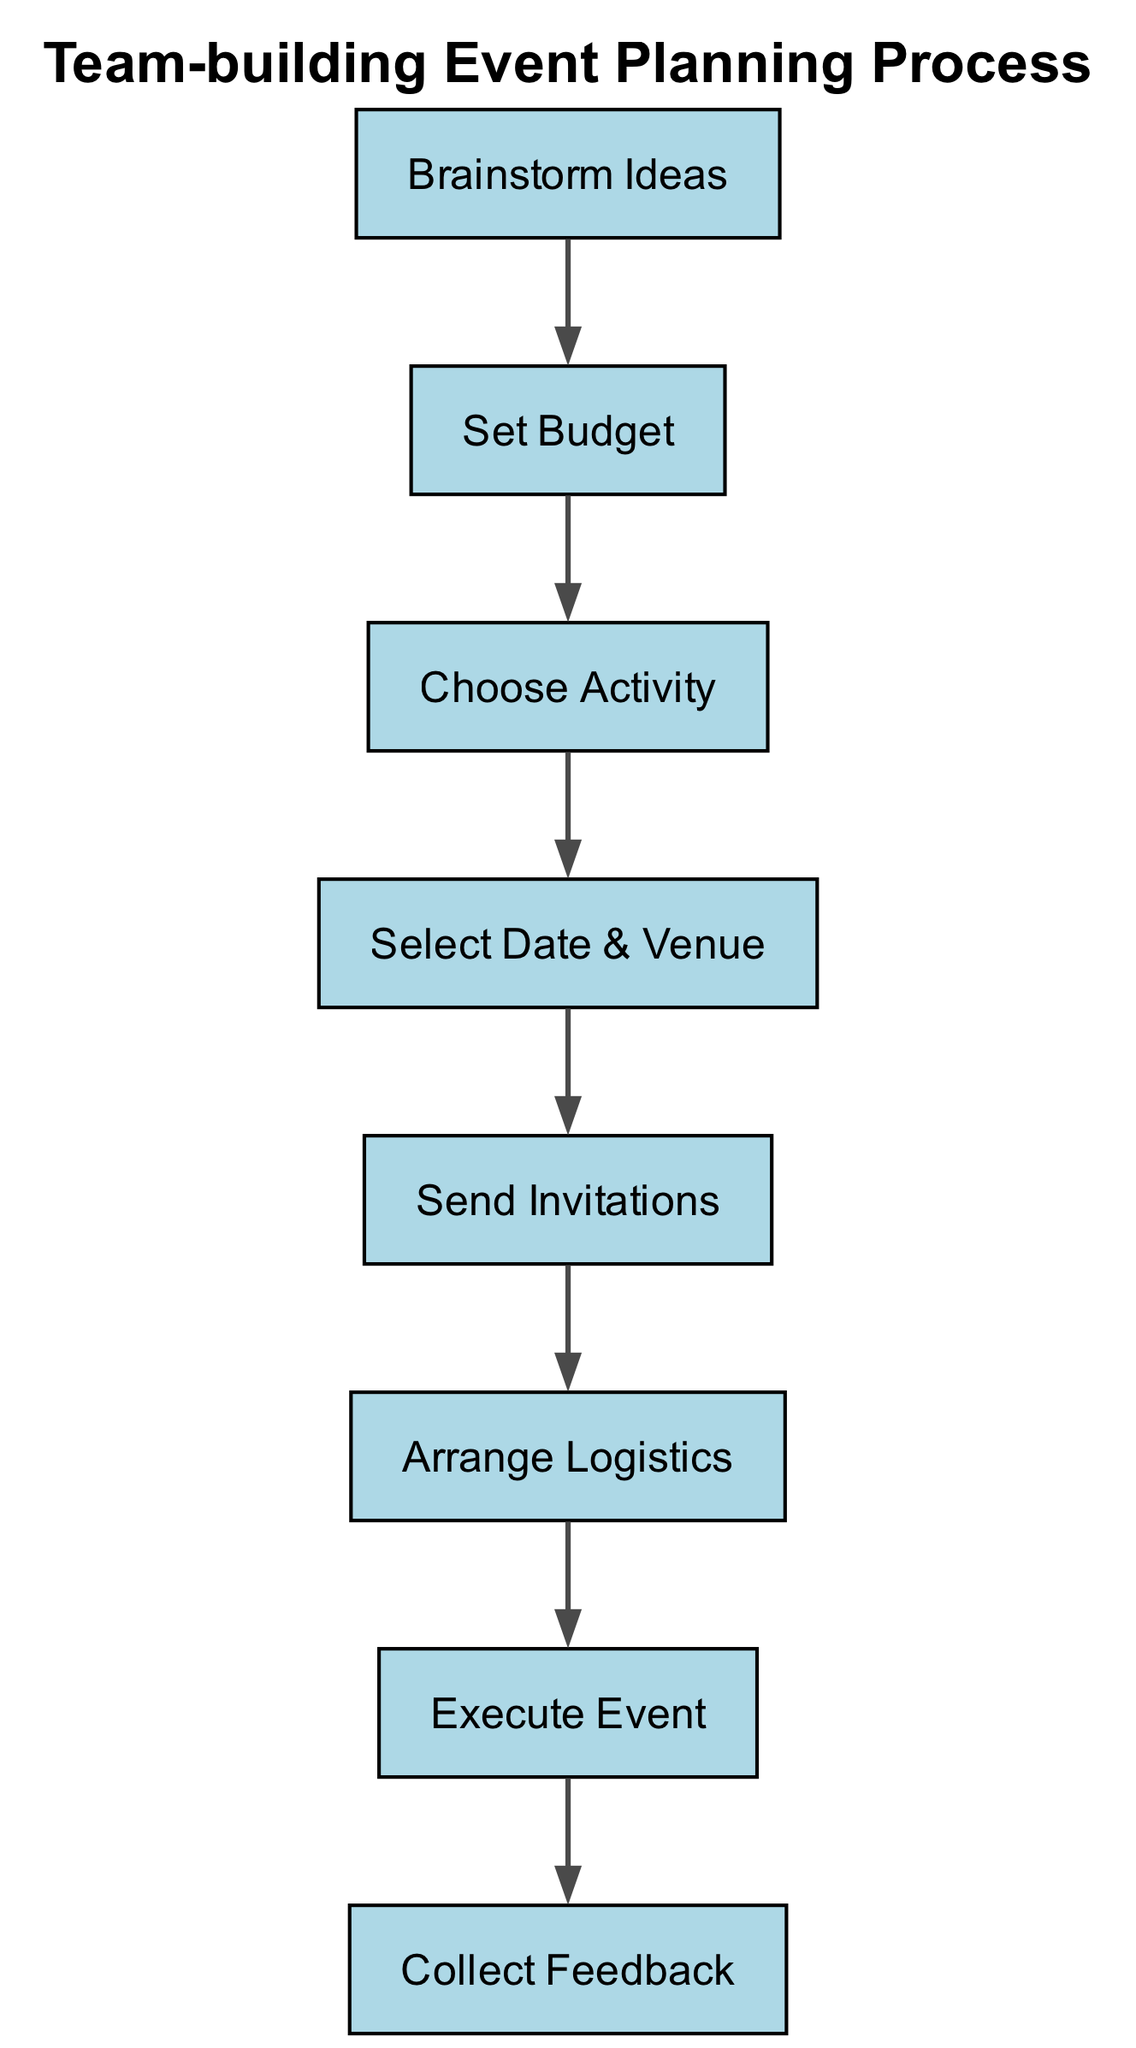What's the total number of nodes in the diagram? Counting the nodes in the diagram, there are a total of 8 distinct stages represented: Brainstorm Ideas, Set Budget, Choose Activity, Select Date & Venue, Send Invitations, Arrange Logistics, Execute Event, and Collect Feedback.
Answer: 8 What is the node text associated with ID 4? Looking at the diagram, the node with ID 4 is labeled as "Select Date & Venue."
Answer: Select Date & Venue How many edges are there in the diagram? By examining the connections between nodes, we can see that there are 7 directed edges connecting the different stages of the process.
Answer: 7 What stage follows "Send Invitations"? Referring to the outgoing connection from the "Send Invitations" node, it points to the "Arrange Logistics" node, indicating that this is the next stage in the process after sending out invitations.
Answer: Arrange Logistics Which node precedes "Execute Event"? The diagram shows that "Arrange Logistics" is directly linked to "Execute Event" as its predecessor, indicating that all logistical arrangements must be completed before the event execution.
Answer: Arrange Logistics What is the first stage in the event planning process? The diagram clearly shows that "Brainstorm Ideas" is the starting point in the event planning process, marking the initiation of the entire workflow.
Answer: Brainstorm Ideas Which node connects to "Collect Feedback"? The only node leading into "Collect Feedback" is "Execute Event," signifying that collecting feedback is the final step following the event execution.
Answer: Execute Event Is there a direct connection from "Set Budget" to "Send Invitations"? Analyzing the edges, there is no direct connection from "Set Budget" to "Send Invitations"; instead, the process moves sequentially through "Choose Activity" and "Select Date & Venue" before reaching "Send Invitations."
Answer: No What is the relationship between "Choose Activity" and "Set Budget"? The flow from "Set Budget" to "Choose Activity" shows that budgeting is an input that helps determine the choices of activities, indicating a preparatory relationship where the budget influences the selection of activities.
Answer: Sequential influence 